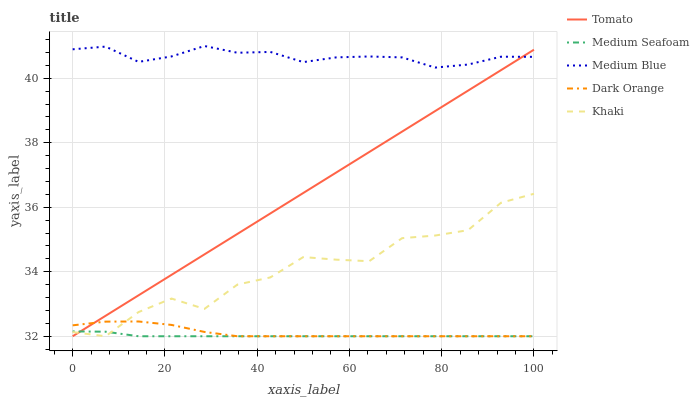Does Medium Seafoam have the minimum area under the curve?
Answer yes or no. Yes. Does Medium Blue have the maximum area under the curve?
Answer yes or no. Yes. Does Dark Orange have the minimum area under the curve?
Answer yes or no. No. Does Dark Orange have the maximum area under the curve?
Answer yes or no. No. Is Tomato the smoothest?
Answer yes or no. Yes. Is Khaki the roughest?
Answer yes or no. Yes. Is Dark Orange the smoothest?
Answer yes or no. No. Is Dark Orange the roughest?
Answer yes or no. No. Does Tomato have the lowest value?
Answer yes or no. Yes. Does Medium Blue have the lowest value?
Answer yes or no. No. Does Medium Blue have the highest value?
Answer yes or no. Yes. Does Dark Orange have the highest value?
Answer yes or no. No. Is Khaki less than Medium Blue?
Answer yes or no. Yes. Is Medium Blue greater than Medium Seafoam?
Answer yes or no. Yes. Does Khaki intersect Tomato?
Answer yes or no. Yes. Is Khaki less than Tomato?
Answer yes or no. No. Is Khaki greater than Tomato?
Answer yes or no. No. Does Khaki intersect Medium Blue?
Answer yes or no. No. 